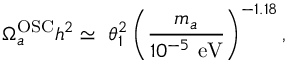<formula> <loc_0><loc_0><loc_500><loc_500>\Omega _ { a } ^ { O S C } h ^ { 2 } \simeq \ \theta _ { 1 } ^ { 2 } \left ( \frac { m _ { a } } { 1 0 ^ { - 5 } \ e V } \right ) ^ { - 1 . 1 8 } ,</formula> 